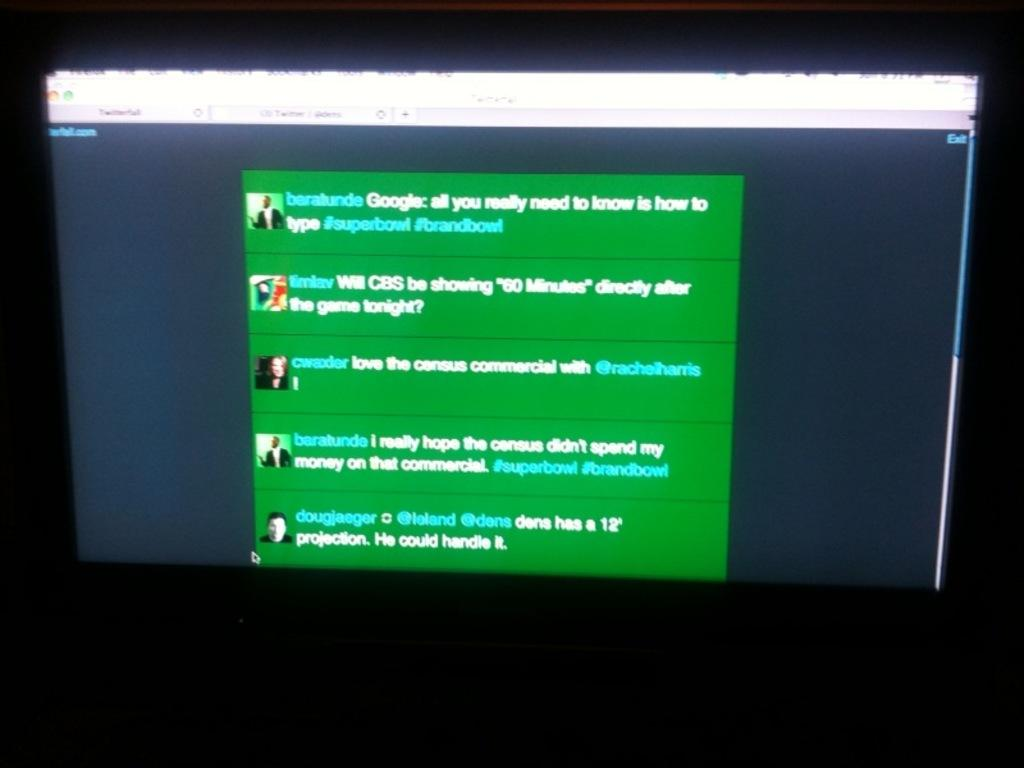What is the main object visible in the image? There is a screen visible in the image. What type of content is displayed on the screen? The screen includes text and images. What type of team is visible on the screen in the image? There is no team visible on the screen in the image; the screen only includes text and images. What type of van is parked next to the screen in the image? There is no van present in the image; the image only features a screen with text and images. 